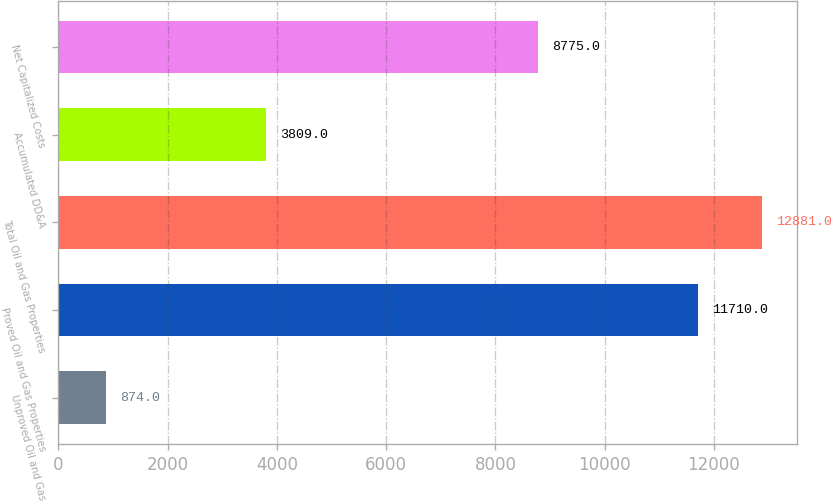Convert chart. <chart><loc_0><loc_0><loc_500><loc_500><bar_chart><fcel>Unproved Oil and Gas<fcel>Proved Oil and Gas Properties<fcel>Total Oil and Gas Properties<fcel>Accumulated DD&A<fcel>Net Capitalized Costs<nl><fcel>874<fcel>11710<fcel>12881<fcel>3809<fcel>8775<nl></chart> 